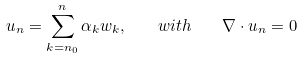<formula> <loc_0><loc_0><loc_500><loc_500>u _ { n } = \sum _ { { k } = { n } _ { 0 } } ^ { n } \alpha _ { k } w _ { k } , \quad w i t h \quad \nabla \cdot u _ { n } = 0</formula> 